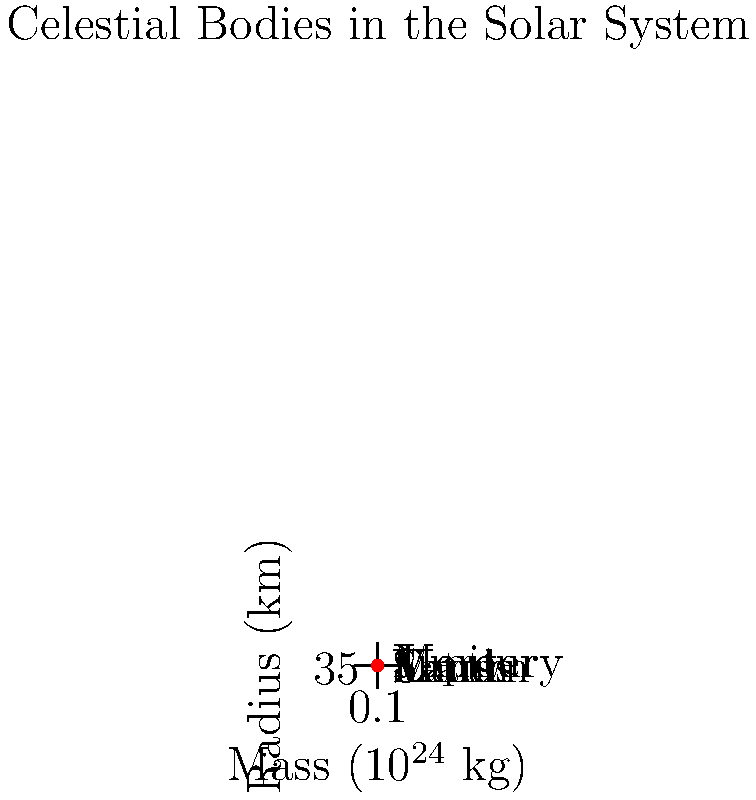Given the graph showing the mass and radius of various celestial bodies in our solar system, calculate the escape velocity for Jupiter. Use the gravitational constant $G = 6.67 \times 10^{-11} \text{ m}^3 \text{kg}^{-1} \text{s}^{-2}$. How does this compare to the escape velocity of Earth? What implications might this have for space exploration and potential plot developments in a science fiction narrative? To solve this problem, we'll follow these steps:

1) The escape velocity formula is:

   $$v_e = \sqrt{\frac{2GM}{R}}$$

   where $G$ is the gravitational constant, $M$ is the mass of the celestial body, and $R$ is its radius.

2) For Jupiter:
   $M_J = 1898 \times 10^{24} \text{ kg}$
   $R_J = 69911 \text{ km} = 69911000 \text{ m}$

3) Plugging these values into the formula:

   $$v_e = \sqrt{\frac{2 \times (6.67 \times 10^{-11}) \times (1898 \times 10^{24})}{69911000}}$$

4) Calculating:
   $$v_e \approx 59.5 \text{ km/s}$$

5) For Earth:
   $M_E = 5.97 \times 10^{24} \text{ kg}$
   $R_E = 6371 \text{ km} = 6371000 \text{ m}$

6) Earth's escape velocity:

   $$v_e = \sqrt{\frac{2 \times (6.67 \times 10^{-11}) \times (5.97 \times 10^{24})}{6371000}} \approx 11.2 \text{ km/s}$$

7) Jupiter's escape velocity is about 5.3 times greater than Earth's.

This significant difference in escape velocities has major implications for space exploration and potential science fiction narratives:

- Launching spacecraft from Jupiter would require much more powerful rockets.
- Entering Jupiter's atmosphere at high speeds could lead to intense heat shields for probes.
- The high escape velocity could make Jupiter an excellent "cosmic slingshot" for deep space missions.
- In a narrative, this could create challenges for characters trying to leave Jupiter or its moons, or opportunities for high-speed space travel using Jupiter's gravity.
Answer: Jupiter's escape velocity: 59.5 km/s, ~5.3 times Earth's (11.2 km/s). 